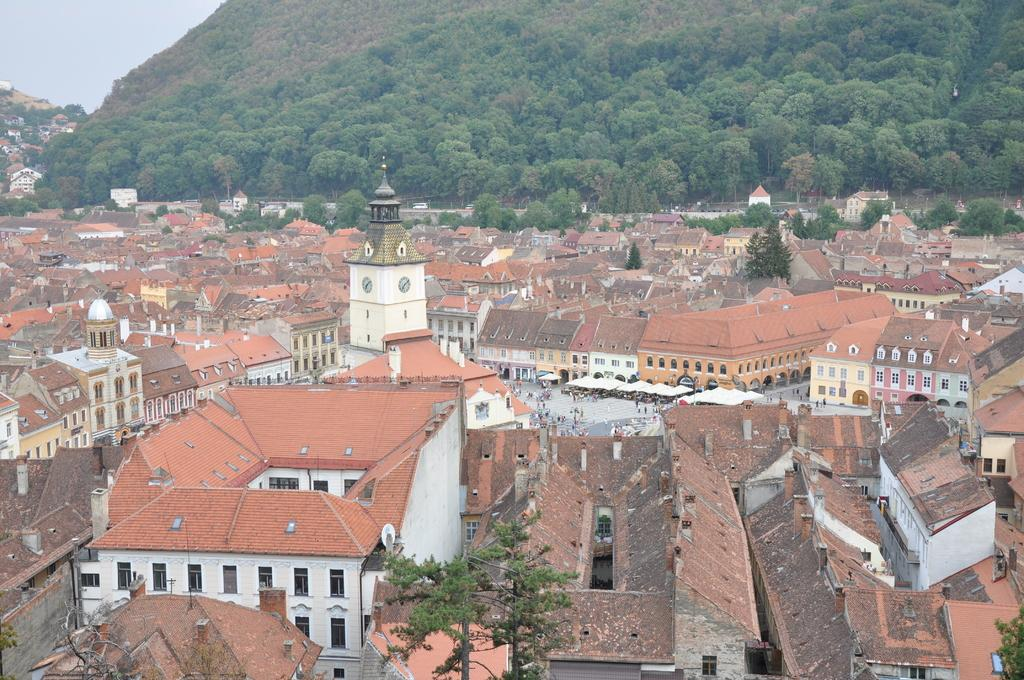What type of structures can be seen in the image? There are houses in the image. Are there any living beings present in the image? Yes, there are people in the image. What can be seen beneath the structures and people? The ground is visible in the image. What type of vegetation is present in the image? There are trees in the image. What type of temporary shelters can be seen in the image? There are tents in the image. What type of natural formation is visible in the image? There are hills in the image. What is visible above the structures, people, and vegetation? The sky is visible in the image. What type of plastic can be seen on the base of the hill in the image? There is no plastic visible on the base of the hill in the image. What type of cap is worn by the trees in the image? The trees in the image do not have caps; they are natural vegetation. 